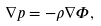Convert formula to latex. <formula><loc_0><loc_0><loc_500><loc_500>\nabla p = - \rho \nabla \Phi ,</formula> 